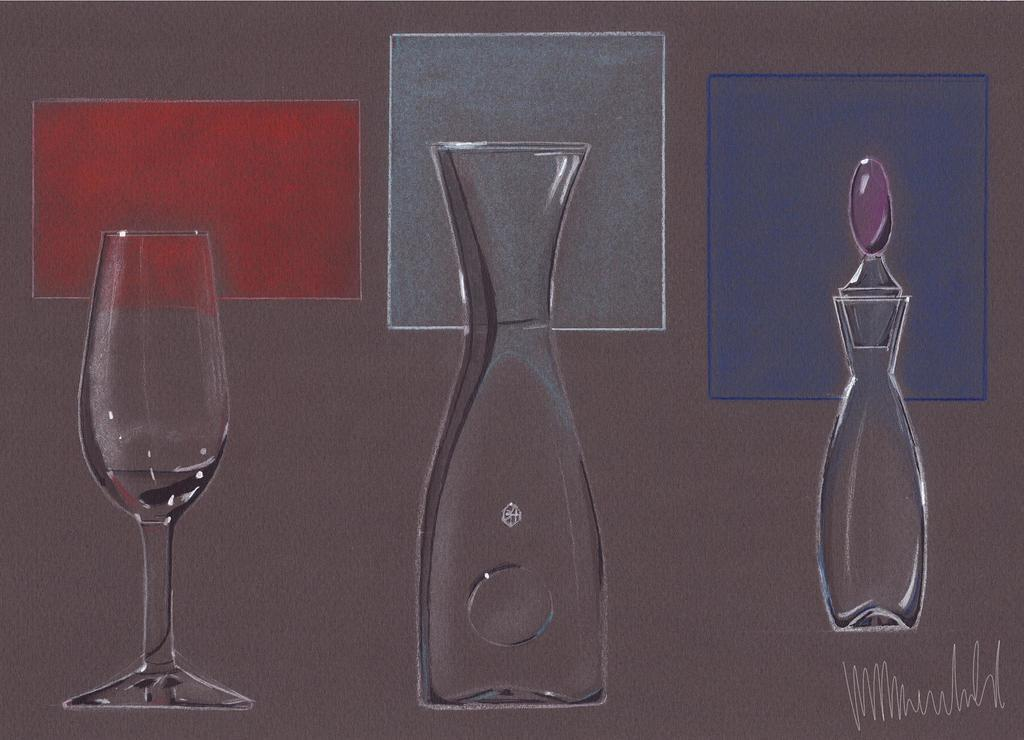What is the main subject of the image? There is a drawing in the image. How many glasses can be seen in the image? There are three glasses in the image. What colors are the boxes in the background of the image? There is a red box, a blue box, and a gray box in the background of the image. Can you tell me how many grapes are on the table in the image? There is no table or grapes present in the image. What type of tiger can be seen interacting with the drawing in the image? There is no tiger present in the image; it only features a drawing, glasses, and boxes. 